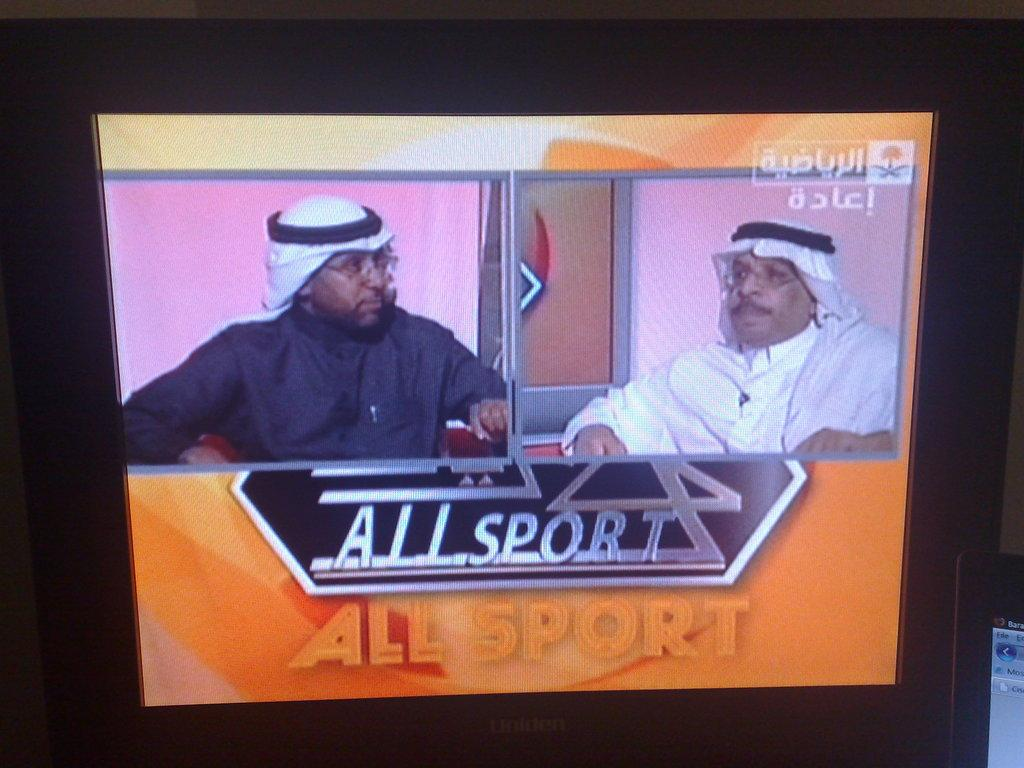How many people are in the image? There are two men in the image. What colors are the dresses of the two men? One man is wearing a black dress, and the other man is wearing a white dress. Can you describe any text or writing visible in the image? Yes, there is writing visible at a few places in the image. What type of apparatus can be seen in the background of the image? There is no apparatus visible in the background of the image. Can you tell me if this image was taken in an office or library? The provided facts do not give any information about the location or setting of the image, so it cannot be determined if it was taken in an office or library. 